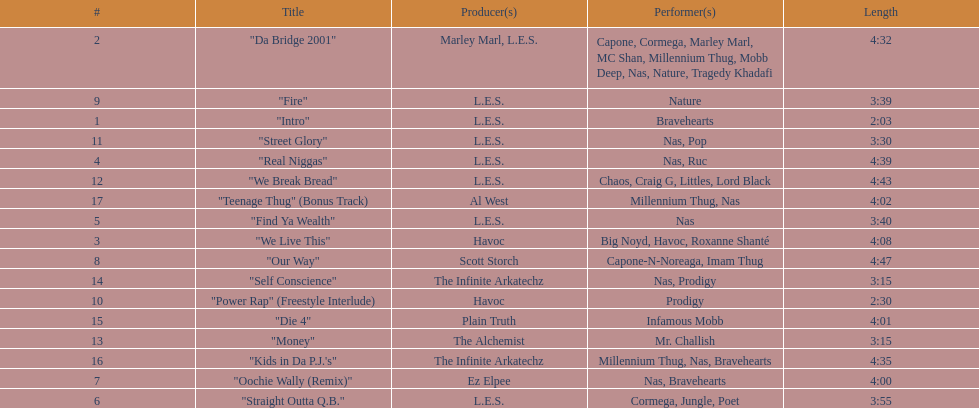How long is the shortest song on the album? 2:03. 